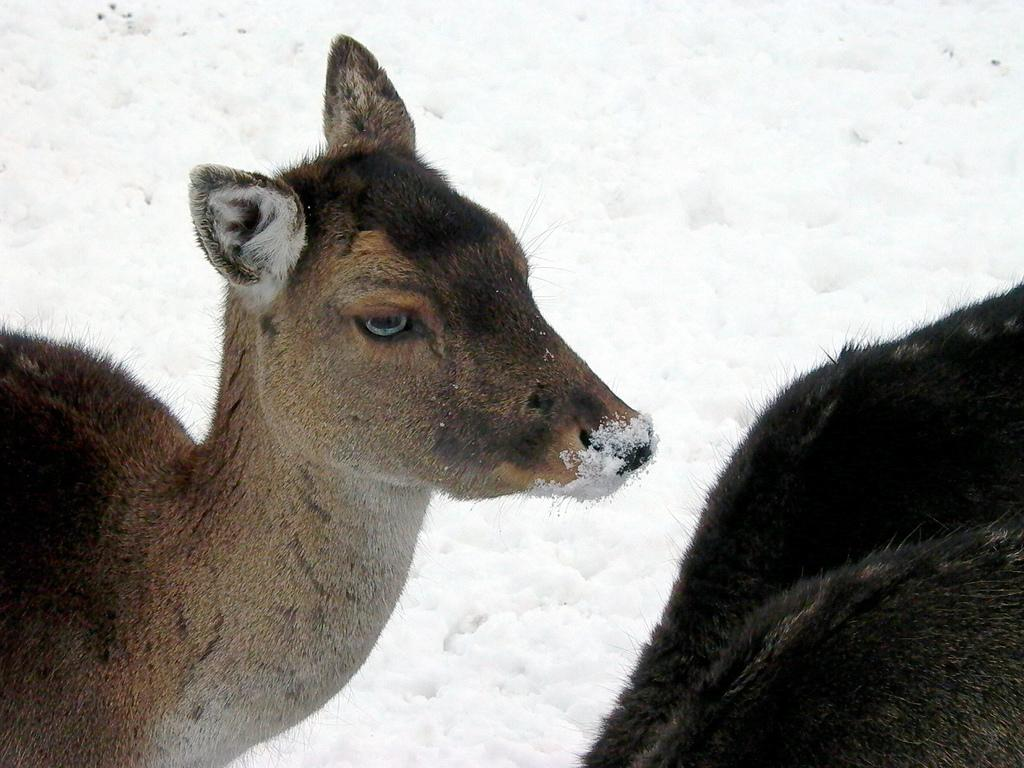What is the main subject in the center of the image? There is an animal in the center of the image. What can be seen in the background of the image? There is snow in the background of the image. How many friends does the man have in the image? There is no man or friends present in the image; it features an animal and snow in the background. 